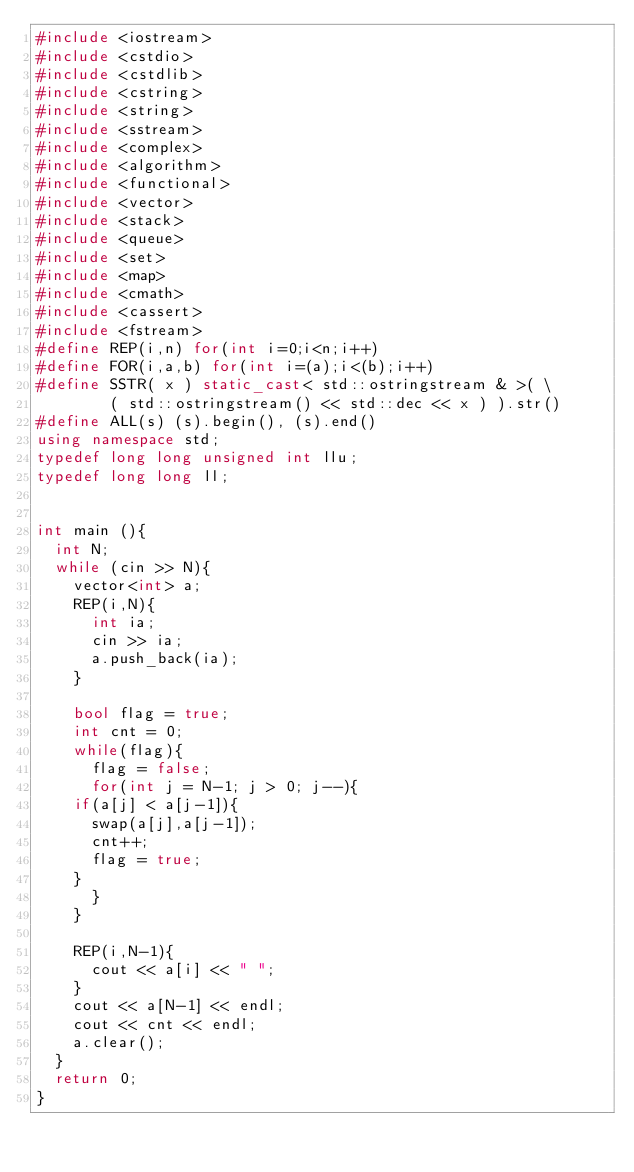Convert code to text. <code><loc_0><loc_0><loc_500><loc_500><_C++_>#include <iostream>
#include <cstdio>
#include <cstdlib>
#include <cstring>
#include <string>
#include <sstream>
#include <complex>
#include <algorithm>
#include <functional>
#include <vector>
#include <stack>
#include <queue>
#include <set>
#include <map>
#include <cmath>
#include <cassert>
#include <fstream>
#define REP(i,n) for(int i=0;i<n;i++)
#define FOR(i,a,b) for(int i=(a);i<(b);i++)
#define SSTR( x ) static_cast< std::ostringstream & >( \
        ( std::ostringstream() << std::dec << x ) ).str()
#define ALL(s) (s).begin(), (s).end()
using namespace std;
typedef long long unsigned int llu;
typedef long long ll;


int main (){
  int N;
  while (cin >> N){
    vector<int> a;
    REP(i,N){
      int ia;
      cin >> ia;
      a.push_back(ia);
    }

    bool flag = true;
    int cnt = 0;
    while(flag){
      flag = false;
      for(int j = N-1; j > 0; j--){
	if(a[j] < a[j-1]){
	  swap(a[j],a[j-1]);
	  cnt++;
	  flag = true;
	}
      }
    }
    
    REP(i,N-1){
      cout << a[i] << " ";
    }
    cout << a[N-1] << endl;
    cout << cnt << endl;
    a.clear();
  }
  return 0;
}

</code> 